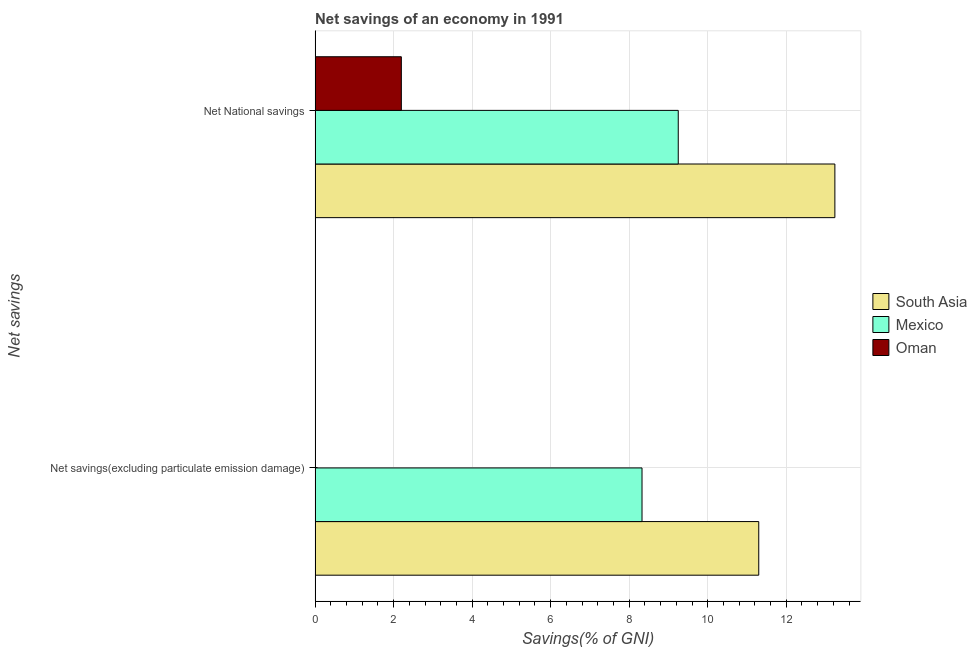How many different coloured bars are there?
Offer a terse response. 3. Are the number of bars on each tick of the Y-axis equal?
Your answer should be very brief. No. What is the label of the 2nd group of bars from the top?
Provide a succinct answer. Net savings(excluding particulate emission damage). What is the net savings(excluding particulate emission damage) in South Asia?
Your answer should be very brief. 11.3. Across all countries, what is the maximum net national savings?
Offer a terse response. 13.24. In which country was the net national savings maximum?
Ensure brevity in your answer.  South Asia. What is the total net savings(excluding particulate emission damage) in the graph?
Your answer should be very brief. 19.63. What is the difference between the net national savings in South Asia and that in Oman?
Give a very brief answer. 11.04. What is the difference between the net national savings in Mexico and the net savings(excluding particulate emission damage) in South Asia?
Provide a succinct answer. -2.05. What is the average net national savings per country?
Make the answer very short. 8.23. What is the difference between the net national savings and net savings(excluding particulate emission damage) in South Asia?
Give a very brief answer. 1.94. In how many countries, is the net savings(excluding particulate emission damage) greater than 12.4 %?
Provide a short and direct response. 0. What is the ratio of the net national savings in South Asia to that in Mexico?
Offer a very short reply. 1.43. In how many countries, is the net savings(excluding particulate emission damage) greater than the average net savings(excluding particulate emission damage) taken over all countries?
Ensure brevity in your answer.  2. Are all the bars in the graph horizontal?
Keep it short and to the point. Yes. Does the graph contain grids?
Your response must be concise. Yes. What is the title of the graph?
Offer a terse response. Net savings of an economy in 1991. Does "Yemen, Rep." appear as one of the legend labels in the graph?
Provide a short and direct response. No. What is the label or title of the X-axis?
Offer a terse response. Savings(% of GNI). What is the label or title of the Y-axis?
Make the answer very short. Net savings. What is the Savings(% of GNI) of South Asia in Net savings(excluding particulate emission damage)?
Give a very brief answer. 11.3. What is the Savings(% of GNI) of Mexico in Net savings(excluding particulate emission damage)?
Your answer should be very brief. 8.33. What is the Savings(% of GNI) in South Asia in Net National savings?
Provide a short and direct response. 13.24. What is the Savings(% of GNI) in Mexico in Net National savings?
Your answer should be compact. 9.25. What is the Savings(% of GNI) in Oman in Net National savings?
Offer a terse response. 2.2. Across all Net savings, what is the maximum Savings(% of GNI) of South Asia?
Provide a succinct answer. 13.24. Across all Net savings, what is the maximum Savings(% of GNI) in Mexico?
Keep it short and to the point. 9.25. Across all Net savings, what is the maximum Savings(% of GNI) in Oman?
Ensure brevity in your answer.  2.2. Across all Net savings, what is the minimum Savings(% of GNI) in South Asia?
Your response must be concise. 11.3. Across all Net savings, what is the minimum Savings(% of GNI) in Mexico?
Your answer should be compact. 8.33. What is the total Savings(% of GNI) in South Asia in the graph?
Your answer should be compact. 24.54. What is the total Savings(% of GNI) in Mexico in the graph?
Your answer should be very brief. 17.58. What is the total Savings(% of GNI) in Oman in the graph?
Provide a short and direct response. 2.2. What is the difference between the Savings(% of GNI) in South Asia in Net savings(excluding particulate emission damage) and that in Net National savings?
Offer a very short reply. -1.94. What is the difference between the Savings(% of GNI) of Mexico in Net savings(excluding particulate emission damage) and that in Net National savings?
Provide a succinct answer. -0.92. What is the difference between the Savings(% of GNI) of South Asia in Net savings(excluding particulate emission damage) and the Savings(% of GNI) of Mexico in Net National savings?
Offer a terse response. 2.05. What is the difference between the Savings(% of GNI) of South Asia in Net savings(excluding particulate emission damage) and the Savings(% of GNI) of Oman in Net National savings?
Keep it short and to the point. 9.1. What is the difference between the Savings(% of GNI) in Mexico in Net savings(excluding particulate emission damage) and the Savings(% of GNI) in Oman in Net National savings?
Your answer should be very brief. 6.13. What is the average Savings(% of GNI) of South Asia per Net savings?
Your answer should be compact. 12.27. What is the average Savings(% of GNI) in Mexico per Net savings?
Your response must be concise. 8.79. What is the average Savings(% of GNI) in Oman per Net savings?
Provide a short and direct response. 1.1. What is the difference between the Savings(% of GNI) in South Asia and Savings(% of GNI) in Mexico in Net savings(excluding particulate emission damage)?
Give a very brief answer. 2.97. What is the difference between the Savings(% of GNI) of South Asia and Savings(% of GNI) of Mexico in Net National savings?
Make the answer very short. 3.99. What is the difference between the Savings(% of GNI) in South Asia and Savings(% of GNI) in Oman in Net National savings?
Offer a terse response. 11.04. What is the difference between the Savings(% of GNI) of Mexico and Savings(% of GNI) of Oman in Net National savings?
Provide a short and direct response. 7.05. What is the ratio of the Savings(% of GNI) in South Asia in Net savings(excluding particulate emission damage) to that in Net National savings?
Provide a succinct answer. 0.85. What is the ratio of the Savings(% of GNI) in Mexico in Net savings(excluding particulate emission damage) to that in Net National savings?
Keep it short and to the point. 0.9. What is the difference between the highest and the second highest Savings(% of GNI) in South Asia?
Your response must be concise. 1.94. What is the difference between the highest and the second highest Savings(% of GNI) of Mexico?
Give a very brief answer. 0.92. What is the difference between the highest and the lowest Savings(% of GNI) of South Asia?
Give a very brief answer. 1.94. What is the difference between the highest and the lowest Savings(% of GNI) in Mexico?
Provide a succinct answer. 0.92. What is the difference between the highest and the lowest Savings(% of GNI) of Oman?
Make the answer very short. 2.2. 